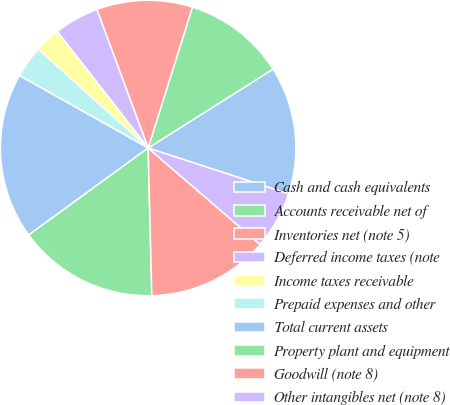Convert chart. <chart><loc_0><loc_0><loc_500><loc_500><pie_chart><fcel>Cash and cash equivalents<fcel>Accounts receivable net of<fcel>Inventories net (note 5)<fcel>Deferred income taxes (note<fcel>Income taxes receivable<fcel>Prepaid expenses and other<fcel>Total current assets<fcel>Property plant and equipment<fcel>Goodwill (note 8)<fcel>Other intangibles net (note 8)<nl><fcel>13.99%<fcel>11.19%<fcel>10.49%<fcel>4.9%<fcel>2.8%<fcel>3.5%<fcel>18.18%<fcel>15.38%<fcel>13.29%<fcel>6.29%<nl></chart> 